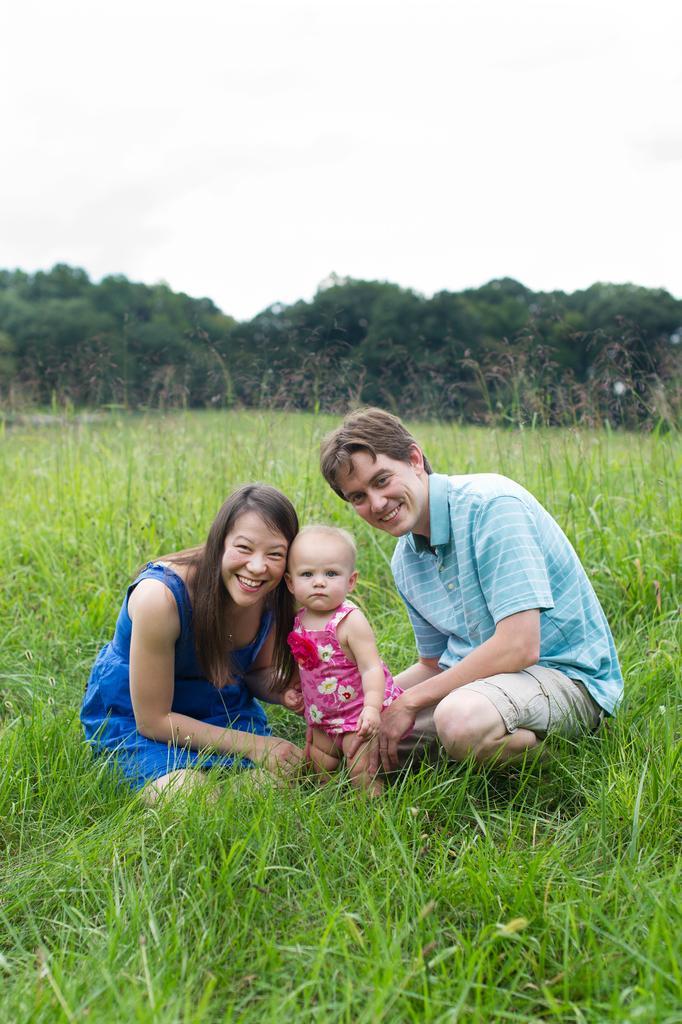Describe this image in one or two sentences. In this image I can see an open grass ground and on it I can see a woman, a man and a child. I can also see smile on few faces and in the background I can see number of trees. I can see this image is little bit blurry from background. 